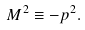Convert formula to latex. <formula><loc_0><loc_0><loc_500><loc_500>M ^ { 2 } \equiv - p ^ { 2 } .</formula> 